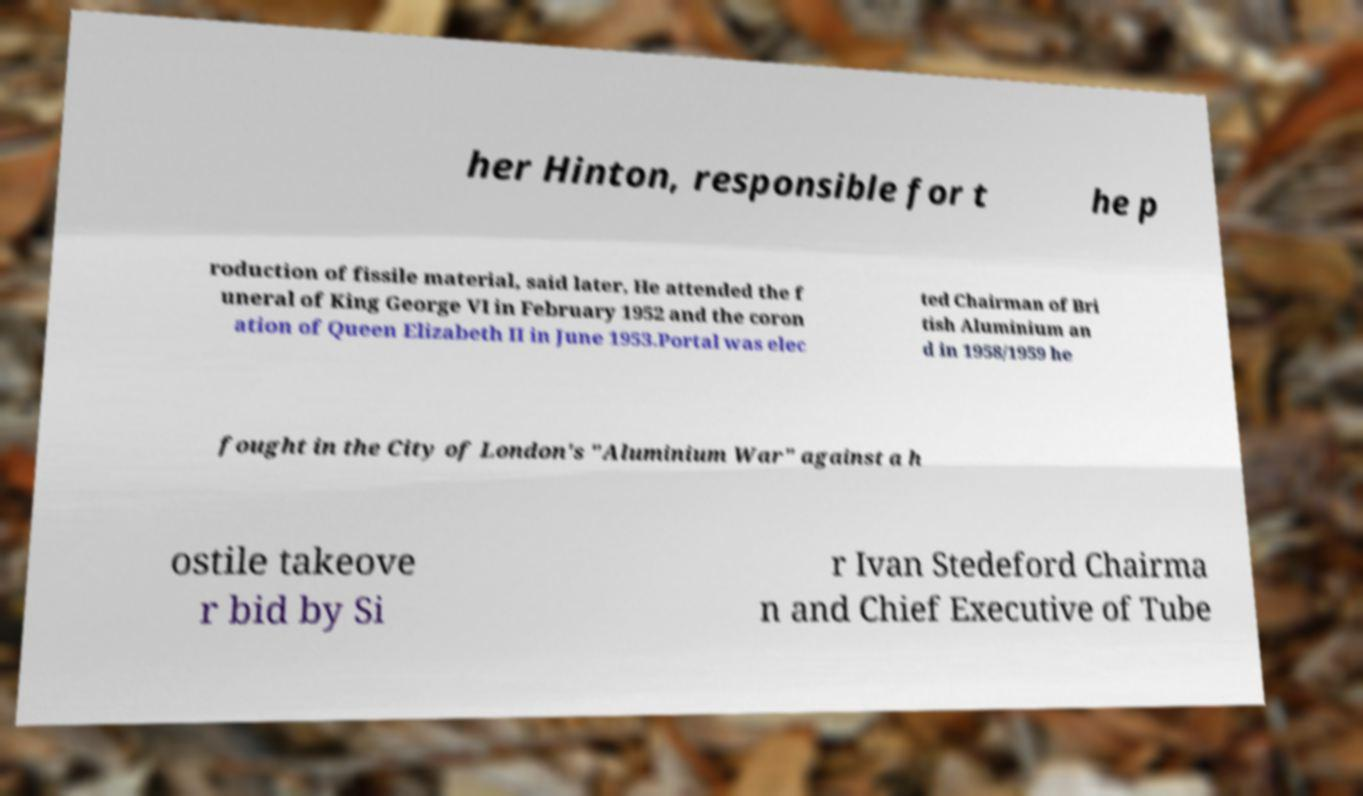I need the written content from this picture converted into text. Can you do that? her Hinton, responsible for t he p roduction of fissile material, said later, He attended the f uneral of King George VI in February 1952 and the coron ation of Queen Elizabeth II in June 1953.Portal was elec ted Chairman of Bri tish Aluminium an d in 1958/1959 he fought in the City of London's "Aluminium War" against a h ostile takeove r bid by Si r Ivan Stedeford Chairma n and Chief Executive of Tube 